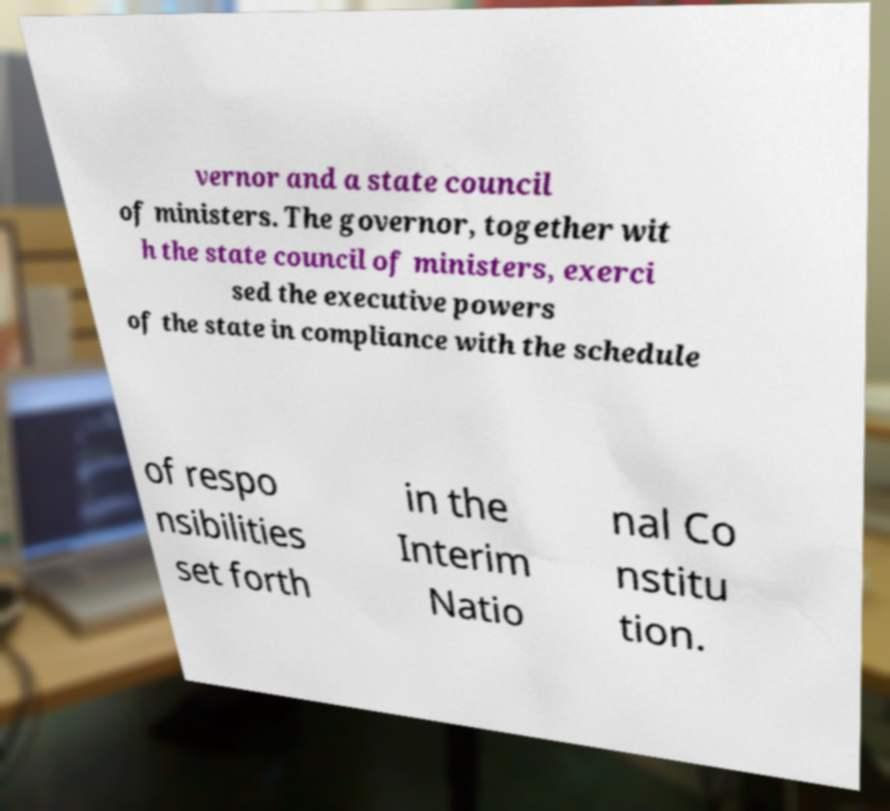Please identify and transcribe the text found in this image. vernor and a state council of ministers. The governor, together wit h the state council of ministers, exerci sed the executive powers of the state in compliance with the schedule of respo nsibilities set forth in the Interim Natio nal Co nstitu tion. 